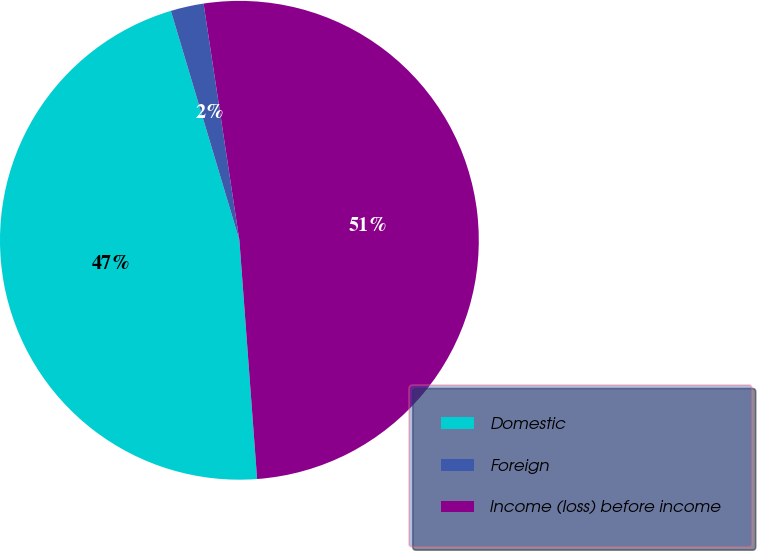<chart> <loc_0><loc_0><loc_500><loc_500><pie_chart><fcel>Domestic<fcel>Foreign<fcel>Income (loss) before income<nl><fcel>46.56%<fcel>2.23%<fcel>51.21%<nl></chart> 